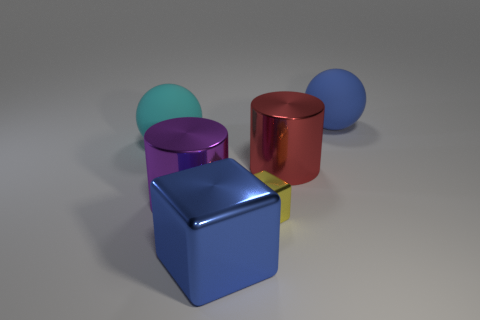What number of big blue matte objects are left of the blue object that is in front of the rubber object to the left of the big red metal object?
Provide a short and direct response. 0. Is the number of large blue metallic blocks that are on the left side of the large cyan rubber ball the same as the number of purple metallic cylinders that are on the right side of the big red object?
Provide a succinct answer. Yes. How many cyan objects have the same shape as the purple shiny object?
Offer a very short reply. 0. Is there another large block that has the same material as the large blue block?
Make the answer very short. No. The thing that is the same color as the large metal cube is what shape?
Your response must be concise. Sphere. How many cyan matte balls are there?
Your response must be concise. 1. How many blocks are big yellow metallic things or big cyan matte things?
Keep it short and to the point. 0. The metallic cube that is the same size as the purple thing is what color?
Provide a succinct answer. Blue. How many large blue objects are both behind the blue cube and in front of the large red thing?
Ensure brevity in your answer.  0. What is the yellow object made of?
Your answer should be compact. Metal. 